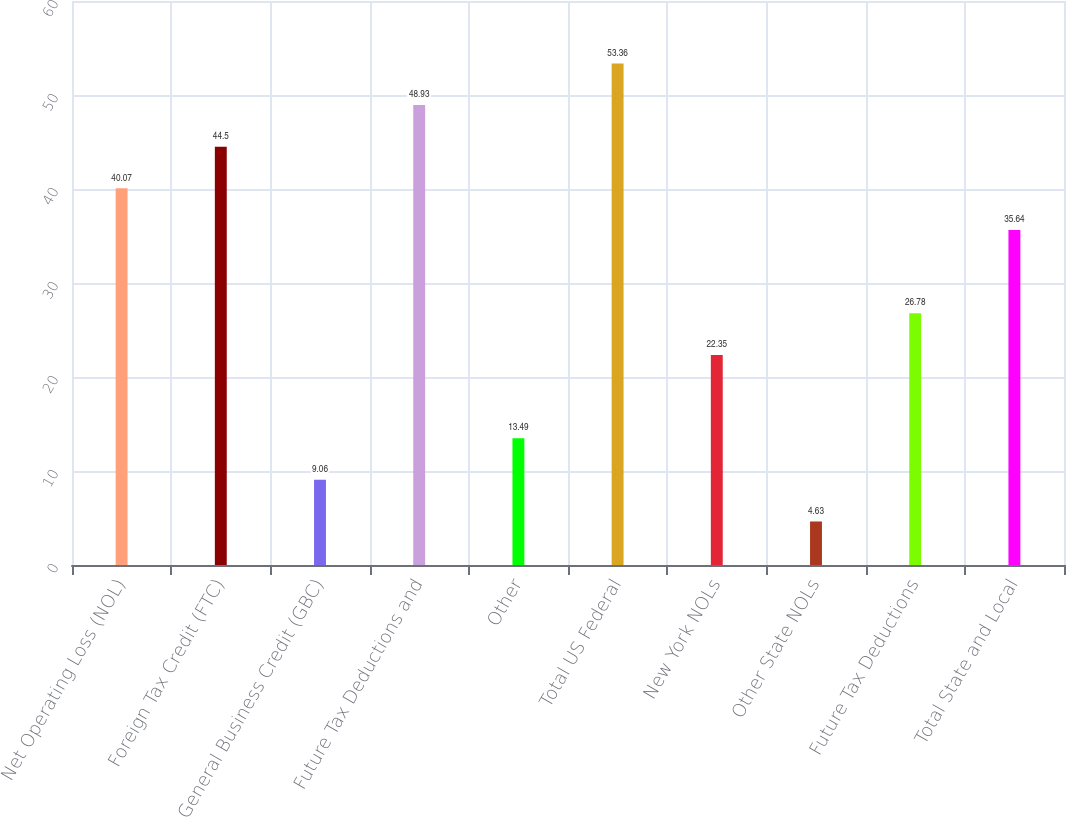Convert chart to OTSL. <chart><loc_0><loc_0><loc_500><loc_500><bar_chart><fcel>Net Operating Loss (NOL)<fcel>Foreign Tax Credit (FTC)<fcel>General Business Credit (GBC)<fcel>Future Tax Deductions and<fcel>Other<fcel>Total US Federal<fcel>New York NOLs<fcel>Other State NOLs<fcel>Future Tax Deductions<fcel>Total State and Local<nl><fcel>40.07<fcel>44.5<fcel>9.06<fcel>48.93<fcel>13.49<fcel>53.36<fcel>22.35<fcel>4.63<fcel>26.78<fcel>35.64<nl></chart> 